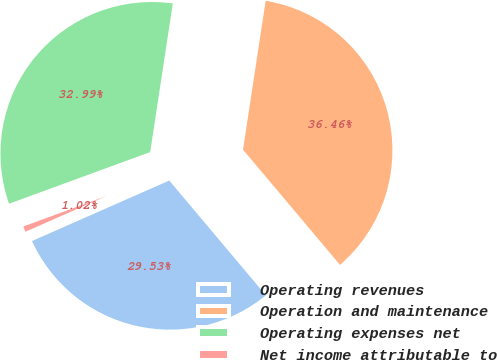Convert chart to OTSL. <chart><loc_0><loc_0><loc_500><loc_500><pie_chart><fcel>Operating revenues<fcel>Operation and maintenance<fcel>Operating expenses net<fcel>Net income attributable to<nl><fcel>29.53%<fcel>36.46%<fcel>32.99%<fcel>1.02%<nl></chart> 